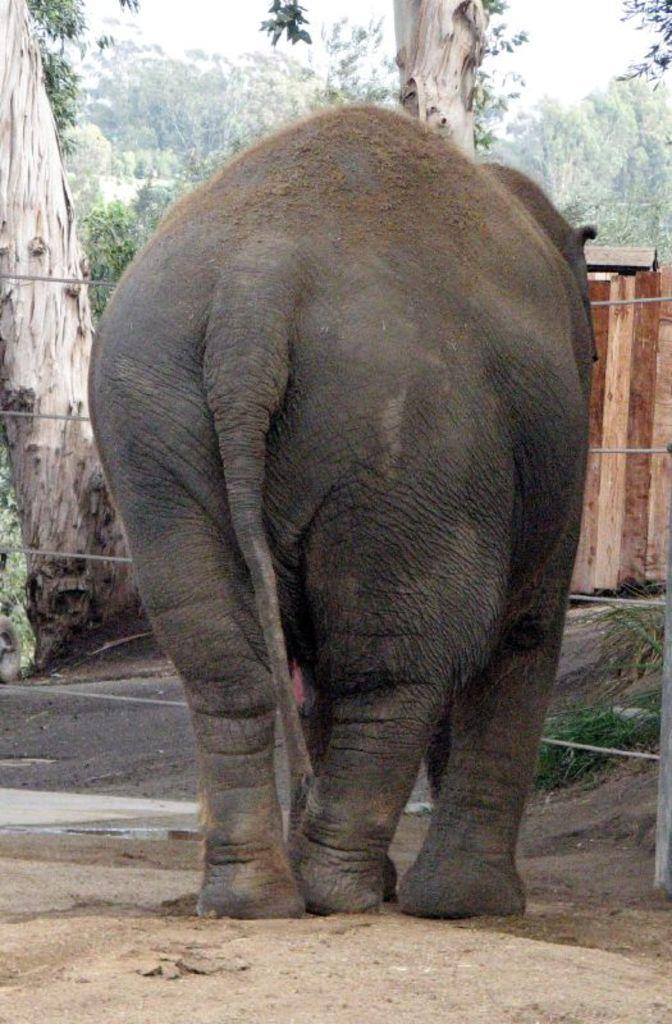What animal is the main subject of the image? There is an elephant in the image. What is the color of the elephant? The elephant is black in color. What type of terrain is visible in the image? There is soil visible in the image. What can be seen in the background of the image? There are wires, wooden fencing, and trees in the background of the image. How many errors can be found in the image? There is no mention of errors in the image, so it is not possible to determine the number of errors. Can you see any ants in the image? There are no ants present in the image. 